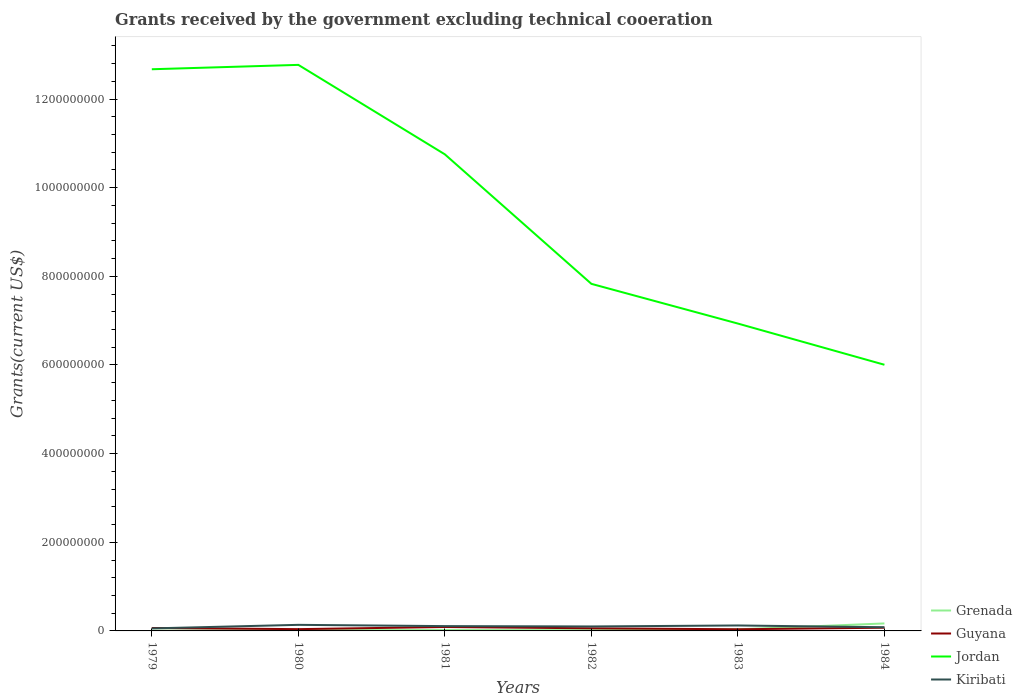Across all years, what is the maximum total grants received by the government in Guyana?
Offer a terse response. 3.74e+06. In which year was the total grants received by the government in Kiribati maximum?
Ensure brevity in your answer.  1979. What is the total total grants received by the government in Kiribati in the graph?
Ensure brevity in your answer.  -1.44e+06. What is the difference between the highest and the second highest total grants received by the government in Jordan?
Your response must be concise. 6.77e+08. Is the total grants received by the government in Kiribati strictly greater than the total grants received by the government in Guyana over the years?
Keep it short and to the point. No. How many lines are there?
Offer a terse response. 4. How many years are there in the graph?
Provide a short and direct response. 6. Are the values on the major ticks of Y-axis written in scientific E-notation?
Keep it short and to the point. No. Does the graph contain any zero values?
Your answer should be very brief. No. Does the graph contain grids?
Ensure brevity in your answer.  No. How are the legend labels stacked?
Provide a succinct answer. Vertical. What is the title of the graph?
Keep it short and to the point. Grants received by the government excluding technical cooeration. What is the label or title of the Y-axis?
Keep it short and to the point. Grants(current US$). What is the Grants(current US$) of Guyana in 1979?
Your response must be concise. 6.62e+06. What is the Grants(current US$) of Jordan in 1979?
Offer a very short reply. 1.27e+09. What is the Grants(current US$) in Kiribati in 1979?
Offer a very short reply. 5.69e+06. What is the Grants(current US$) of Grenada in 1980?
Your answer should be very brief. 1.70e+06. What is the Grants(current US$) of Guyana in 1980?
Your response must be concise. 4.01e+06. What is the Grants(current US$) of Jordan in 1980?
Ensure brevity in your answer.  1.28e+09. What is the Grants(current US$) of Kiribati in 1980?
Your answer should be compact. 1.37e+07. What is the Grants(current US$) in Grenada in 1981?
Offer a very short reply. 2.05e+06. What is the Grants(current US$) of Guyana in 1981?
Your response must be concise. 8.82e+06. What is the Grants(current US$) in Jordan in 1981?
Offer a terse response. 1.08e+09. What is the Grants(current US$) of Kiribati in 1981?
Offer a terse response. 1.09e+07. What is the Grants(current US$) in Grenada in 1982?
Offer a terse response. 1.69e+06. What is the Grants(current US$) of Guyana in 1982?
Make the answer very short. 5.87e+06. What is the Grants(current US$) in Jordan in 1982?
Provide a short and direct response. 7.83e+08. What is the Grants(current US$) in Kiribati in 1982?
Offer a terse response. 1.01e+07. What is the Grants(current US$) of Grenada in 1983?
Ensure brevity in your answer.  3.51e+06. What is the Grants(current US$) of Guyana in 1983?
Your answer should be compact. 3.74e+06. What is the Grants(current US$) of Jordan in 1983?
Your answer should be compact. 6.93e+08. What is the Grants(current US$) of Kiribati in 1983?
Give a very brief answer. 1.23e+07. What is the Grants(current US$) of Grenada in 1984?
Ensure brevity in your answer.  1.69e+07. What is the Grants(current US$) of Guyana in 1984?
Your answer should be very brief. 7.25e+06. What is the Grants(current US$) of Jordan in 1984?
Offer a terse response. 6.00e+08. What is the Grants(current US$) of Kiribati in 1984?
Your answer should be compact. 8.29e+06. Across all years, what is the maximum Grants(current US$) of Grenada?
Provide a short and direct response. 1.69e+07. Across all years, what is the maximum Grants(current US$) of Guyana?
Keep it short and to the point. 8.82e+06. Across all years, what is the maximum Grants(current US$) in Jordan?
Your response must be concise. 1.28e+09. Across all years, what is the maximum Grants(current US$) in Kiribati?
Make the answer very short. 1.37e+07. Across all years, what is the minimum Grants(current US$) in Grenada?
Keep it short and to the point. 4.50e+05. Across all years, what is the minimum Grants(current US$) of Guyana?
Provide a short and direct response. 3.74e+06. Across all years, what is the minimum Grants(current US$) in Jordan?
Provide a short and direct response. 6.00e+08. Across all years, what is the minimum Grants(current US$) of Kiribati?
Your response must be concise. 5.69e+06. What is the total Grants(current US$) of Grenada in the graph?
Keep it short and to the point. 2.63e+07. What is the total Grants(current US$) in Guyana in the graph?
Your answer should be very brief. 3.63e+07. What is the total Grants(current US$) of Jordan in the graph?
Give a very brief answer. 5.70e+09. What is the total Grants(current US$) of Kiribati in the graph?
Offer a very short reply. 6.10e+07. What is the difference between the Grants(current US$) in Grenada in 1979 and that in 1980?
Give a very brief answer. -1.25e+06. What is the difference between the Grants(current US$) in Guyana in 1979 and that in 1980?
Offer a very short reply. 2.61e+06. What is the difference between the Grants(current US$) of Jordan in 1979 and that in 1980?
Offer a very short reply. -9.88e+06. What is the difference between the Grants(current US$) in Kiribati in 1979 and that in 1980?
Your answer should be very brief. -8.03e+06. What is the difference between the Grants(current US$) in Grenada in 1979 and that in 1981?
Your response must be concise. -1.60e+06. What is the difference between the Grants(current US$) of Guyana in 1979 and that in 1981?
Your answer should be very brief. -2.20e+06. What is the difference between the Grants(current US$) in Jordan in 1979 and that in 1981?
Your answer should be compact. 1.92e+08. What is the difference between the Grants(current US$) in Kiribati in 1979 and that in 1981?
Keep it short and to the point. -5.17e+06. What is the difference between the Grants(current US$) of Grenada in 1979 and that in 1982?
Offer a terse response. -1.24e+06. What is the difference between the Grants(current US$) of Guyana in 1979 and that in 1982?
Ensure brevity in your answer.  7.50e+05. What is the difference between the Grants(current US$) in Jordan in 1979 and that in 1982?
Your response must be concise. 4.84e+08. What is the difference between the Grants(current US$) in Kiribati in 1979 and that in 1982?
Your answer should be compact. -4.40e+06. What is the difference between the Grants(current US$) of Grenada in 1979 and that in 1983?
Keep it short and to the point. -3.06e+06. What is the difference between the Grants(current US$) in Guyana in 1979 and that in 1983?
Give a very brief answer. 2.88e+06. What is the difference between the Grants(current US$) in Jordan in 1979 and that in 1983?
Keep it short and to the point. 5.74e+08. What is the difference between the Grants(current US$) in Kiribati in 1979 and that in 1983?
Provide a succinct answer. -6.61e+06. What is the difference between the Grants(current US$) in Grenada in 1979 and that in 1984?
Provide a short and direct response. -1.64e+07. What is the difference between the Grants(current US$) in Guyana in 1979 and that in 1984?
Your answer should be very brief. -6.30e+05. What is the difference between the Grants(current US$) of Jordan in 1979 and that in 1984?
Keep it short and to the point. 6.67e+08. What is the difference between the Grants(current US$) in Kiribati in 1979 and that in 1984?
Make the answer very short. -2.60e+06. What is the difference between the Grants(current US$) in Grenada in 1980 and that in 1981?
Offer a terse response. -3.50e+05. What is the difference between the Grants(current US$) in Guyana in 1980 and that in 1981?
Your response must be concise. -4.81e+06. What is the difference between the Grants(current US$) in Jordan in 1980 and that in 1981?
Keep it short and to the point. 2.02e+08. What is the difference between the Grants(current US$) of Kiribati in 1980 and that in 1981?
Provide a succinct answer. 2.86e+06. What is the difference between the Grants(current US$) in Grenada in 1980 and that in 1982?
Offer a very short reply. 10000. What is the difference between the Grants(current US$) of Guyana in 1980 and that in 1982?
Provide a succinct answer. -1.86e+06. What is the difference between the Grants(current US$) of Jordan in 1980 and that in 1982?
Your answer should be compact. 4.94e+08. What is the difference between the Grants(current US$) of Kiribati in 1980 and that in 1982?
Give a very brief answer. 3.63e+06. What is the difference between the Grants(current US$) in Grenada in 1980 and that in 1983?
Provide a succinct answer. -1.81e+06. What is the difference between the Grants(current US$) in Guyana in 1980 and that in 1983?
Make the answer very short. 2.70e+05. What is the difference between the Grants(current US$) of Jordan in 1980 and that in 1983?
Your answer should be very brief. 5.84e+08. What is the difference between the Grants(current US$) of Kiribati in 1980 and that in 1983?
Keep it short and to the point. 1.42e+06. What is the difference between the Grants(current US$) of Grenada in 1980 and that in 1984?
Your answer should be very brief. -1.52e+07. What is the difference between the Grants(current US$) of Guyana in 1980 and that in 1984?
Offer a very short reply. -3.24e+06. What is the difference between the Grants(current US$) of Jordan in 1980 and that in 1984?
Offer a very short reply. 6.77e+08. What is the difference between the Grants(current US$) of Kiribati in 1980 and that in 1984?
Your response must be concise. 5.43e+06. What is the difference between the Grants(current US$) of Guyana in 1981 and that in 1982?
Provide a short and direct response. 2.95e+06. What is the difference between the Grants(current US$) in Jordan in 1981 and that in 1982?
Your answer should be compact. 2.92e+08. What is the difference between the Grants(current US$) in Kiribati in 1981 and that in 1982?
Your answer should be very brief. 7.70e+05. What is the difference between the Grants(current US$) in Grenada in 1981 and that in 1983?
Offer a terse response. -1.46e+06. What is the difference between the Grants(current US$) of Guyana in 1981 and that in 1983?
Offer a very short reply. 5.08e+06. What is the difference between the Grants(current US$) in Jordan in 1981 and that in 1983?
Ensure brevity in your answer.  3.82e+08. What is the difference between the Grants(current US$) of Kiribati in 1981 and that in 1983?
Provide a succinct answer. -1.44e+06. What is the difference between the Grants(current US$) in Grenada in 1981 and that in 1984?
Offer a very short reply. -1.48e+07. What is the difference between the Grants(current US$) of Guyana in 1981 and that in 1984?
Make the answer very short. 1.57e+06. What is the difference between the Grants(current US$) of Jordan in 1981 and that in 1984?
Offer a terse response. 4.75e+08. What is the difference between the Grants(current US$) of Kiribati in 1981 and that in 1984?
Your answer should be very brief. 2.57e+06. What is the difference between the Grants(current US$) of Grenada in 1982 and that in 1983?
Offer a very short reply. -1.82e+06. What is the difference between the Grants(current US$) in Guyana in 1982 and that in 1983?
Give a very brief answer. 2.13e+06. What is the difference between the Grants(current US$) of Jordan in 1982 and that in 1983?
Make the answer very short. 8.96e+07. What is the difference between the Grants(current US$) in Kiribati in 1982 and that in 1983?
Give a very brief answer. -2.21e+06. What is the difference between the Grants(current US$) of Grenada in 1982 and that in 1984?
Your answer should be compact. -1.52e+07. What is the difference between the Grants(current US$) of Guyana in 1982 and that in 1984?
Your answer should be compact. -1.38e+06. What is the difference between the Grants(current US$) of Jordan in 1982 and that in 1984?
Make the answer very short. 1.83e+08. What is the difference between the Grants(current US$) in Kiribati in 1982 and that in 1984?
Offer a terse response. 1.80e+06. What is the difference between the Grants(current US$) in Grenada in 1983 and that in 1984?
Give a very brief answer. -1.34e+07. What is the difference between the Grants(current US$) of Guyana in 1983 and that in 1984?
Offer a terse response. -3.51e+06. What is the difference between the Grants(current US$) in Jordan in 1983 and that in 1984?
Ensure brevity in your answer.  9.29e+07. What is the difference between the Grants(current US$) in Kiribati in 1983 and that in 1984?
Your response must be concise. 4.01e+06. What is the difference between the Grants(current US$) in Grenada in 1979 and the Grants(current US$) in Guyana in 1980?
Provide a short and direct response. -3.56e+06. What is the difference between the Grants(current US$) in Grenada in 1979 and the Grants(current US$) in Jordan in 1980?
Provide a short and direct response. -1.28e+09. What is the difference between the Grants(current US$) in Grenada in 1979 and the Grants(current US$) in Kiribati in 1980?
Give a very brief answer. -1.33e+07. What is the difference between the Grants(current US$) of Guyana in 1979 and the Grants(current US$) of Jordan in 1980?
Your answer should be very brief. -1.27e+09. What is the difference between the Grants(current US$) in Guyana in 1979 and the Grants(current US$) in Kiribati in 1980?
Offer a terse response. -7.10e+06. What is the difference between the Grants(current US$) in Jordan in 1979 and the Grants(current US$) in Kiribati in 1980?
Offer a very short reply. 1.25e+09. What is the difference between the Grants(current US$) in Grenada in 1979 and the Grants(current US$) in Guyana in 1981?
Provide a short and direct response. -8.37e+06. What is the difference between the Grants(current US$) in Grenada in 1979 and the Grants(current US$) in Jordan in 1981?
Your answer should be very brief. -1.07e+09. What is the difference between the Grants(current US$) in Grenada in 1979 and the Grants(current US$) in Kiribati in 1981?
Offer a very short reply. -1.04e+07. What is the difference between the Grants(current US$) of Guyana in 1979 and the Grants(current US$) of Jordan in 1981?
Your answer should be very brief. -1.07e+09. What is the difference between the Grants(current US$) of Guyana in 1979 and the Grants(current US$) of Kiribati in 1981?
Offer a terse response. -4.24e+06. What is the difference between the Grants(current US$) in Jordan in 1979 and the Grants(current US$) in Kiribati in 1981?
Make the answer very short. 1.26e+09. What is the difference between the Grants(current US$) in Grenada in 1979 and the Grants(current US$) in Guyana in 1982?
Provide a succinct answer. -5.42e+06. What is the difference between the Grants(current US$) of Grenada in 1979 and the Grants(current US$) of Jordan in 1982?
Make the answer very short. -7.83e+08. What is the difference between the Grants(current US$) of Grenada in 1979 and the Grants(current US$) of Kiribati in 1982?
Give a very brief answer. -9.64e+06. What is the difference between the Grants(current US$) of Guyana in 1979 and the Grants(current US$) of Jordan in 1982?
Offer a terse response. -7.76e+08. What is the difference between the Grants(current US$) in Guyana in 1979 and the Grants(current US$) in Kiribati in 1982?
Provide a succinct answer. -3.47e+06. What is the difference between the Grants(current US$) of Jordan in 1979 and the Grants(current US$) of Kiribati in 1982?
Offer a very short reply. 1.26e+09. What is the difference between the Grants(current US$) in Grenada in 1979 and the Grants(current US$) in Guyana in 1983?
Your answer should be compact. -3.29e+06. What is the difference between the Grants(current US$) of Grenada in 1979 and the Grants(current US$) of Jordan in 1983?
Make the answer very short. -6.93e+08. What is the difference between the Grants(current US$) in Grenada in 1979 and the Grants(current US$) in Kiribati in 1983?
Make the answer very short. -1.18e+07. What is the difference between the Grants(current US$) in Guyana in 1979 and the Grants(current US$) in Jordan in 1983?
Ensure brevity in your answer.  -6.87e+08. What is the difference between the Grants(current US$) in Guyana in 1979 and the Grants(current US$) in Kiribati in 1983?
Your answer should be compact. -5.68e+06. What is the difference between the Grants(current US$) of Jordan in 1979 and the Grants(current US$) of Kiribati in 1983?
Your answer should be very brief. 1.25e+09. What is the difference between the Grants(current US$) in Grenada in 1979 and the Grants(current US$) in Guyana in 1984?
Offer a very short reply. -6.80e+06. What is the difference between the Grants(current US$) of Grenada in 1979 and the Grants(current US$) of Jordan in 1984?
Make the answer very short. -6.00e+08. What is the difference between the Grants(current US$) in Grenada in 1979 and the Grants(current US$) in Kiribati in 1984?
Offer a very short reply. -7.84e+06. What is the difference between the Grants(current US$) of Guyana in 1979 and the Grants(current US$) of Jordan in 1984?
Provide a succinct answer. -5.94e+08. What is the difference between the Grants(current US$) of Guyana in 1979 and the Grants(current US$) of Kiribati in 1984?
Your response must be concise. -1.67e+06. What is the difference between the Grants(current US$) in Jordan in 1979 and the Grants(current US$) in Kiribati in 1984?
Ensure brevity in your answer.  1.26e+09. What is the difference between the Grants(current US$) of Grenada in 1980 and the Grants(current US$) of Guyana in 1981?
Offer a very short reply. -7.12e+06. What is the difference between the Grants(current US$) in Grenada in 1980 and the Grants(current US$) in Jordan in 1981?
Your response must be concise. -1.07e+09. What is the difference between the Grants(current US$) in Grenada in 1980 and the Grants(current US$) in Kiribati in 1981?
Keep it short and to the point. -9.16e+06. What is the difference between the Grants(current US$) in Guyana in 1980 and the Grants(current US$) in Jordan in 1981?
Your answer should be very brief. -1.07e+09. What is the difference between the Grants(current US$) in Guyana in 1980 and the Grants(current US$) in Kiribati in 1981?
Provide a short and direct response. -6.85e+06. What is the difference between the Grants(current US$) of Jordan in 1980 and the Grants(current US$) of Kiribati in 1981?
Keep it short and to the point. 1.27e+09. What is the difference between the Grants(current US$) of Grenada in 1980 and the Grants(current US$) of Guyana in 1982?
Provide a succinct answer. -4.17e+06. What is the difference between the Grants(current US$) of Grenada in 1980 and the Grants(current US$) of Jordan in 1982?
Provide a short and direct response. -7.81e+08. What is the difference between the Grants(current US$) in Grenada in 1980 and the Grants(current US$) in Kiribati in 1982?
Keep it short and to the point. -8.39e+06. What is the difference between the Grants(current US$) of Guyana in 1980 and the Grants(current US$) of Jordan in 1982?
Provide a succinct answer. -7.79e+08. What is the difference between the Grants(current US$) in Guyana in 1980 and the Grants(current US$) in Kiribati in 1982?
Provide a short and direct response. -6.08e+06. What is the difference between the Grants(current US$) in Jordan in 1980 and the Grants(current US$) in Kiribati in 1982?
Provide a short and direct response. 1.27e+09. What is the difference between the Grants(current US$) of Grenada in 1980 and the Grants(current US$) of Guyana in 1983?
Give a very brief answer. -2.04e+06. What is the difference between the Grants(current US$) in Grenada in 1980 and the Grants(current US$) in Jordan in 1983?
Make the answer very short. -6.92e+08. What is the difference between the Grants(current US$) of Grenada in 1980 and the Grants(current US$) of Kiribati in 1983?
Ensure brevity in your answer.  -1.06e+07. What is the difference between the Grants(current US$) in Guyana in 1980 and the Grants(current US$) in Jordan in 1983?
Offer a terse response. -6.89e+08. What is the difference between the Grants(current US$) in Guyana in 1980 and the Grants(current US$) in Kiribati in 1983?
Make the answer very short. -8.29e+06. What is the difference between the Grants(current US$) in Jordan in 1980 and the Grants(current US$) in Kiribati in 1983?
Keep it short and to the point. 1.26e+09. What is the difference between the Grants(current US$) of Grenada in 1980 and the Grants(current US$) of Guyana in 1984?
Ensure brevity in your answer.  -5.55e+06. What is the difference between the Grants(current US$) in Grenada in 1980 and the Grants(current US$) in Jordan in 1984?
Offer a terse response. -5.99e+08. What is the difference between the Grants(current US$) in Grenada in 1980 and the Grants(current US$) in Kiribati in 1984?
Provide a succinct answer. -6.59e+06. What is the difference between the Grants(current US$) in Guyana in 1980 and the Grants(current US$) in Jordan in 1984?
Ensure brevity in your answer.  -5.96e+08. What is the difference between the Grants(current US$) of Guyana in 1980 and the Grants(current US$) of Kiribati in 1984?
Your answer should be very brief. -4.28e+06. What is the difference between the Grants(current US$) in Jordan in 1980 and the Grants(current US$) in Kiribati in 1984?
Ensure brevity in your answer.  1.27e+09. What is the difference between the Grants(current US$) of Grenada in 1981 and the Grants(current US$) of Guyana in 1982?
Ensure brevity in your answer.  -3.82e+06. What is the difference between the Grants(current US$) in Grenada in 1981 and the Grants(current US$) in Jordan in 1982?
Your answer should be compact. -7.81e+08. What is the difference between the Grants(current US$) of Grenada in 1981 and the Grants(current US$) of Kiribati in 1982?
Offer a very short reply. -8.04e+06. What is the difference between the Grants(current US$) of Guyana in 1981 and the Grants(current US$) of Jordan in 1982?
Your answer should be compact. -7.74e+08. What is the difference between the Grants(current US$) in Guyana in 1981 and the Grants(current US$) in Kiribati in 1982?
Give a very brief answer. -1.27e+06. What is the difference between the Grants(current US$) of Jordan in 1981 and the Grants(current US$) of Kiribati in 1982?
Make the answer very short. 1.07e+09. What is the difference between the Grants(current US$) in Grenada in 1981 and the Grants(current US$) in Guyana in 1983?
Ensure brevity in your answer.  -1.69e+06. What is the difference between the Grants(current US$) of Grenada in 1981 and the Grants(current US$) of Jordan in 1983?
Ensure brevity in your answer.  -6.91e+08. What is the difference between the Grants(current US$) in Grenada in 1981 and the Grants(current US$) in Kiribati in 1983?
Provide a succinct answer. -1.02e+07. What is the difference between the Grants(current US$) in Guyana in 1981 and the Grants(current US$) in Jordan in 1983?
Your answer should be compact. -6.85e+08. What is the difference between the Grants(current US$) in Guyana in 1981 and the Grants(current US$) in Kiribati in 1983?
Make the answer very short. -3.48e+06. What is the difference between the Grants(current US$) of Jordan in 1981 and the Grants(current US$) of Kiribati in 1983?
Your answer should be very brief. 1.06e+09. What is the difference between the Grants(current US$) of Grenada in 1981 and the Grants(current US$) of Guyana in 1984?
Make the answer very short. -5.20e+06. What is the difference between the Grants(current US$) of Grenada in 1981 and the Grants(current US$) of Jordan in 1984?
Offer a terse response. -5.98e+08. What is the difference between the Grants(current US$) in Grenada in 1981 and the Grants(current US$) in Kiribati in 1984?
Offer a very short reply. -6.24e+06. What is the difference between the Grants(current US$) in Guyana in 1981 and the Grants(current US$) in Jordan in 1984?
Your answer should be very brief. -5.92e+08. What is the difference between the Grants(current US$) in Guyana in 1981 and the Grants(current US$) in Kiribati in 1984?
Your answer should be compact. 5.30e+05. What is the difference between the Grants(current US$) of Jordan in 1981 and the Grants(current US$) of Kiribati in 1984?
Offer a very short reply. 1.07e+09. What is the difference between the Grants(current US$) of Grenada in 1982 and the Grants(current US$) of Guyana in 1983?
Offer a very short reply. -2.05e+06. What is the difference between the Grants(current US$) of Grenada in 1982 and the Grants(current US$) of Jordan in 1983?
Your response must be concise. -6.92e+08. What is the difference between the Grants(current US$) of Grenada in 1982 and the Grants(current US$) of Kiribati in 1983?
Offer a terse response. -1.06e+07. What is the difference between the Grants(current US$) in Guyana in 1982 and the Grants(current US$) in Jordan in 1983?
Your answer should be very brief. -6.88e+08. What is the difference between the Grants(current US$) in Guyana in 1982 and the Grants(current US$) in Kiribati in 1983?
Your answer should be very brief. -6.43e+06. What is the difference between the Grants(current US$) in Jordan in 1982 and the Grants(current US$) in Kiribati in 1983?
Ensure brevity in your answer.  7.71e+08. What is the difference between the Grants(current US$) of Grenada in 1982 and the Grants(current US$) of Guyana in 1984?
Make the answer very short. -5.56e+06. What is the difference between the Grants(current US$) in Grenada in 1982 and the Grants(current US$) in Jordan in 1984?
Your answer should be compact. -5.99e+08. What is the difference between the Grants(current US$) of Grenada in 1982 and the Grants(current US$) of Kiribati in 1984?
Provide a succinct answer. -6.60e+06. What is the difference between the Grants(current US$) in Guyana in 1982 and the Grants(current US$) in Jordan in 1984?
Your answer should be compact. -5.95e+08. What is the difference between the Grants(current US$) in Guyana in 1982 and the Grants(current US$) in Kiribati in 1984?
Provide a short and direct response. -2.42e+06. What is the difference between the Grants(current US$) of Jordan in 1982 and the Grants(current US$) of Kiribati in 1984?
Provide a short and direct response. 7.75e+08. What is the difference between the Grants(current US$) in Grenada in 1983 and the Grants(current US$) in Guyana in 1984?
Keep it short and to the point. -3.74e+06. What is the difference between the Grants(current US$) in Grenada in 1983 and the Grants(current US$) in Jordan in 1984?
Offer a terse response. -5.97e+08. What is the difference between the Grants(current US$) in Grenada in 1983 and the Grants(current US$) in Kiribati in 1984?
Your answer should be compact. -4.78e+06. What is the difference between the Grants(current US$) of Guyana in 1983 and the Grants(current US$) of Jordan in 1984?
Ensure brevity in your answer.  -5.97e+08. What is the difference between the Grants(current US$) of Guyana in 1983 and the Grants(current US$) of Kiribati in 1984?
Ensure brevity in your answer.  -4.55e+06. What is the difference between the Grants(current US$) of Jordan in 1983 and the Grants(current US$) of Kiribati in 1984?
Provide a succinct answer. 6.85e+08. What is the average Grants(current US$) in Grenada per year?
Your answer should be very brief. 4.38e+06. What is the average Grants(current US$) in Guyana per year?
Keep it short and to the point. 6.05e+06. What is the average Grants(current US$) of Jordan per year?
Your answer should be very brief. 9.49e+08. What is the average Grants(current US$) of Kiribati per year?
Ensure brevity in your answer.  1.02e+07. In the year 1979, what is the difference between the Grants(current US$) in Grenada and Grants(current US$) in Guyana?
Your answer should be very brief. -6.17e+06. In the year 1979, what is the difference between the Grants(current US$) of Grenada and Grants(current US$) of Jordan?
Your response must be concise. -1.27e+09. In the year 1979, what is the difference between the Grants(current US$) in Grenada and Grants(current US$) in Kiribati?
Your response must be concise. -5.24e+06. In the year 1979, what is the difference between the Grants(current US$) of Guyana and Grants(current US$) of Jordan?
Offer a very short reply. -1.26e+09. In the year 1979, what is the difference between the Grants(current US$) of Guyana and Grants(current US$) of Kiribati?
Your response must be concise. 9.30e+05. In the year 1979, what is the difference between the Grants(current US$) in Jordan and Grants(current US$) in Kiribati?
Make the answer very short. 1.26e+09. In the year 1980, what is the difference between the Grants(current US$) in Grenada and Grants(current US$) in Guyana?
Provide a succinct answer. -2.31e+06. In the year 1980, what is the difference between the Grants(current US$) of Grenada and Grants(current US$) of Jordan?
Your answer should be very brief. -1.28e+09. In the year 1980, what is the difference between the Grants(current US$) in Grenada and Grants(current US$) in Kiribati?
Your answer should be very brief. -1.20e+07. In the year 1980, what is the difference between the Grants(current US$) of Guyana and Grants(current US$) of Jordan?
Keep it short and to the point. -1.27e+09. In the year 1980, what is the difference between the Grants(current US$) of Guyana and Grants(current US$) of Kiribati?
Provide a short and direct response. -9.71e+06. In the year 1980, what is the difference between the Grants(current US$) of Jordan and Grants(current US$) of Kiribati?
Your answer should be compact. 1.26e+09. In the year 1981, what is the difference between the Grants(current US$) of Grenada and Grants(current US$) of Guyana?
Offer a terse response. -6.77e+06. In the year 1981, what is the difference between the Grants(current US$) in Grenada and Grants(current US$) in Jordan?
Your response must be concise. -1.07e+09. In the year 1981, what is the difference between the Grants(current US$) of Grenada and Grants(current US$) of Kiribati?
Your answer should be very brief. -8.81e+06. In the year 1981, what is the difference between the Grants(current US$) of Guyana and Grants(current US$) of Jordan?
Your response must be concise. -1.07e+09. In the year 1981, what is the difference between the Grants(current US$) in Guyana and Grants(current US$) in Kiribati?
Give a very brief answer. -2.04e+06. In the year 1981, what is the difference between the Grants(current US$) in Jordan and Grants(current US$) in Kiribati?
Your response must be concise. 1.06e+09. In the year 1982, what is the difference between the Grants(current US$) of Grenada and Grants(current US$) of Guyana?
Give a very brief answer. -4.18e+06. In the year 1982, what is the difference between the Grants(current US$) of Grenada and Grants(current US$) of Jordan?
Ensure brevity in your answer.  -7.81e+08. In the year 1982, what is the difference between the Grants(current US$) in Grenada and Grants(current US$) in Kiribati?
Your answer should be compact. -8.40e+06. In the year 1982, what is the difference between the Grants(current US$) in Guyana and Grants(current US$) in Jordan?
Make the answer very short. -7.77e+08. In the year 1982, what is the difference between the Grants(current US$) of Guyana and Grants(current US$) of Kiribati?
Make the answer very short. -4.22e+06. In the year 1982, what is the difference between the Grants(current US$) in Jordan and Grants(current US$) in Kiribati?
Provide a short and direct response. 7.73e+08. In the year 1983, what is the difference between the Grants(current US$) of Grenada and Grants(current US$) of Guyana?
Offer a very short reply. -2.30e+05. In the year 1983, what is the difference between the Grants(current US$) of Grenada and Grants(current US$) of Jordan?
Offer a terse response. -6.90e+08. In the year 1983, what is the difference between the Grants(current US$) in Grenada and Grants(current US$) in Kiribati?
Ensure brevity in your answer.  -8.79e+06. In the year 1983, what is the difference between the Grants(current US$) in Guyana and Grants(current US$) in Jordan?
Make the answer very short. -6.90e+08. In the year 1983, what is the difference between the Grants(current US$) in Guyana and Grants(current US$) in Kiribati?
Offer a terse response. -8.56e+06. In the year 1983, what is the difference between the Grants(current US$) of Jordan and Grants(current US$) of Kiribati?
Your answer should be very brief. 6.81e+08. In the year 1984, what is the difference between the Grants(current US$) in Grenada and Grants(current US$) in Guyana?
Offer a very short reply. 9.64e+06. In the year 1984, what is the difference between the Grants(current US$) of Grenada and Grants(current US$) of Jordan?
Give a very brief answer. -5.84e+08. In the year 1984, what is the difference between the Grants(current US$) of Grenada and Grants(current US$) of Kiribati?
Your answer should be compact. 8.60e+06. In the year 1984, what is the difference between the Grants(current US$) of Guyana and Grants(current US$) of Jordan?
Give a very brief answer. -5.93e+08. In the year 1984, what is the difference between the Grants(current US$) in Guyana and Grants(current US$) in Kiribati?
Ensure brevity in your answer.  -1.04e+06. In the year 1984, what is the difference between the Grants(current US$) of Jordan and Grants(current US$) of Kiribati?
Provide a succinct answer. 5.92e+08. What is the ratio of the Grants(current US$) in Grenada in 1979 to that in 1980?
Offer a very short reply. 0.26. What is the ratio of the Grants(current US$) in Guyana in 1979 to that in 1980?
Offer a terse response. 1.65. What is the ratio of the Grants(current US$) in Kiribati in 1979 to that in 1980?
Your answer should be compact. 0.41. What is the ratio of the Grants(current US$) in Grenada in 1979 to that in 1981?
Offer a very short reply. 0.22. What is the ratio of the Grants(current US$) in Guyana in 1979 to that in 1981?
Offer a terse response. 0.75. What is the ratio of the Grants(current US$) of Jordan in 1979 to that in 1981?
Keep it short and to the point. 1.18. What is the ratio of the Grants(current US$) of Kiribati in 1979 to that in 1981?
Ensure brevity in your answer.  0.52. What is the ratio of the Grants(current US$) of Grenada in 1979 to that in 1982?
Offer a terse response. 0.27. What is the ratio of the Grants(current US$) of Guyana in 1979 to that in 1982?
Provide a short and direct response. 1.13. What is the ratio of the Grants(current US$) in Jordan in 1979 to that in 1982?
Your answer should be compact. 1.62. What is the ratio of the Grants(current US$) of Kiribati in 1979 to that in 1982?
Provide a short and direct response. 0.56. What is the ratio of the Grants(current US$) in Grenada in 1979 to that in 1983?
Your response must be concise. 0.13. What is the ratio of the Grants(current US$) of Guyana in 1979 to that in 1983?
Keep it short and to the point. 1.77. What is the ratio of the Grants(current US$) of Jordan in 1979 to that in 1983?
Your answer should be very brief. 1.83. What is the ratio of the Grants(current US$) of Kiribati in 1979 to that in 1983?
Provide a succinct answer. 0.46. What is the ratio of the Grants(current US$) of Grenada in 1979 to that in 1984?
Ensure brevity in your answer.  0.03. What is the ratio of the Grants(current US$) of Guyana in 1979 to that in 1984?
Provide a short and direct response. 0.91. What is the ratio of the Grants(current US$) of Jordan in 1979 to that in 1984?
Your answer should be very brief. 2.11. What is the ratio of the Grants(current US$) of Kiribati in 1979 to that in 1984?
Provide a short and direct response. 0.69. What is the ratio of the Grants(current US$) of Grenada in 1980 to that in 1981?
Provide a succinct answer. 0.83. What is the ratio of the Grants(current US$) of Guyana in 1980 to that in 1981?
Your answer should be compact. 0.45. What is the ratio of the Grants(current US$) in Jordan in 1980 to that in 1981?
Ensure brevity in your answer.  1.19. What is the ratio of the Grants(current US$) of Kiribati in 1980 to that in 1981?
Make the answer very short. 1.26. What is the ratio of the Grants(current US$) of Grenada in 1980 to that in 1982?
Your response must be concise. 1.01. What is the ratio of the Grants(current US$) in Guyana in 1980 to that in 1982?
Give a very brief answer. 0.68. What is the ratio of the Grants(current US$) of Jordan in 1980 to that in 1982?
Provide a succinct answer. 1.63. What is the ratio of the Grants(current US$) in Kiribati in 1980 to that in 1982?
Keep it short and to the point. 1.36. What is the ratio of the Grants(current US$) of Grenada in 1980 to that in 1983?
Make the answer very short. 0.48. What is the ratio of the Grants(current US$) in Guyana in 1980 to that in 1983?
Offer a very short reply. 1.07. What is the ratio of the Grants(current US$) of Jordan in 1980 to that in 1983?
Your answer should be very brief. 1.84. What is the ratio of the Grants(current US$) in Kiribati in 1980 to that in 1983?
Make the answer very short. 1.12. What is the ratio of the Grants(current US$) in Grenada in 1980 to that in 1984?
Your answer should be compact. 0.1. What is the ratio of the Grants(current US$) in Guyana in 1980 to that in 1984?
Keep it short and to the point. 0.55. What is the ratio of the Grants(current US$) of Jordan in 1980 to that in 1984?
Ensure brevity in your answer.  2.13. What is the ratio of the Grants(current US$) of Kiribati in 1980 to that in 1984?
Provide a short and direct response. 1.66. What is the ratio of the Grants(current US$) of Grenada in 1981 to that in 1982?
Your answer should be very brief. 1.21. What is the ratio of the Grants(current US$) of Guyana in 1981 to that in 1982?
Keep it short and to the point. 1.5. What is the ratio of the Grants(current US$) in Jordan in 1981 to that in 1982?
Your answer should be compact. 1.37. What is the ratio of the Grants(current US$) of Kiribati in 1981 to that in 1982?
Offer a terse response. 1.08. What is the ratio of the Grants(current US$) of Grenada in 1981 to that in 1983?
Offer a terse response. 0.58. What is the ratio of the Grants(current US$) of Guyana in 1981 to that in 1983?
Provide a succinct answer. 2.36. What is the ratio of the Grants(current US$) of Jordan in 1981 to that in 1983?
Make the answer very short. 1.55. What is the ratio of the Grants(current US$) in Kiribati in 1981 to that in 1983?
Your answer should be compact. 0.88. What is the ratio of the Grants(current US$) of Grenada in 1981 to that in 1984?
Give a very brief answer. 0.12. What is the ratio of the Grants(current US$) in Guyana in 1981 to that in 1984?
Provide a short and direct response. 1.22. What is the ratio of the Grants(current US$) in Jordan in 1981 to that in 1984?
Keep it short and to the point. 1.79. What is the ratio of the Grants(current US$) in Kiribati in 1981 to that in 1984?
Provide a short and direct response. 1.31. What is the ratio of the Grants(current US$) in Grenada in 1982 to that in 1983?
Your answer should be very brief. 0.48. What is the ratio of the Grants(current US$) of Guyana in 1982 to that in 1983?
Keep it short and to the point. 1.57. What is the ratio of the Grants(current US$) of Jordan in 1982 to that in 1983?
Make the answer very short. 1.13. What is the ratio of the Grants(current US$) of Kiribati in 1982 to that in 1983?
Provide a short and direct response. 0.82. What is the ratio of the Grants(current US$) in Grenada in 1982 to that in 1984?
Your answer should be very brief. 0.1. What is the ratio of the Grants(current US$) in Guyana in 1982 to that in 1984?
Offer a terse response. 0.81. What is the ratio of the Grants(current US$) in Jordan in 1982 to that in 1984?
Your answer should be compact. 1.3. What is the ratio of the Grants(current US$) of Kiribati in 1982 to that in 1984?
Provide a short and direct response. 1.22. What is the ratio of the Grants(current US$) of Grenada in 1983 to that in 1984?
Offer a very short reply. 0.21. What is the ratio of the Grants(current US$) in Guyana in 1983 to that in 1984?
Keep it short and to the point. 0.52. What is the ratio of the Grants(current US$) in Jordan in 1983 to that in 1984?
Make the answer very short. 1.15. What is the ratio of the Grants(current US$) of Kiribati in 1983 to that in 1984?
Make the answer very short. 1.48. What is the difference between the highest and the second highest Grants(current US$) of Grenada?
Keep it short and to the point. 1.34e+07. What is the difference between the highest and the second highest Grants(current US$) in Guyana?
Make the answer very short. 1.57e+06. What is the difference between the highest and the second highest Grants(current US$) of Jordan?
Give a very brief answer. 9.88e+06. What is the difference between the highest and the second highest Grants(current US$) in Kiribati?
Offer a very short reply. 1.42e+06. What is the difference between the highest and the lowest Grants(current US$) of Grenada?
Give a very brief answer. 1.64e+07. What is the difference between the highest and the lowest Grants(current US$) of Guyana?
Keep it short and to the point. 5.08e+06. What is the difference between the highest and the lowest Grants(current US$) in Jordan?
Give a very brief answer. 6.77e+08. What is the difference between the highest and the lowest Grants(current US$) of Kiribati?
Provide a short and direct response. 8.03e+06. 